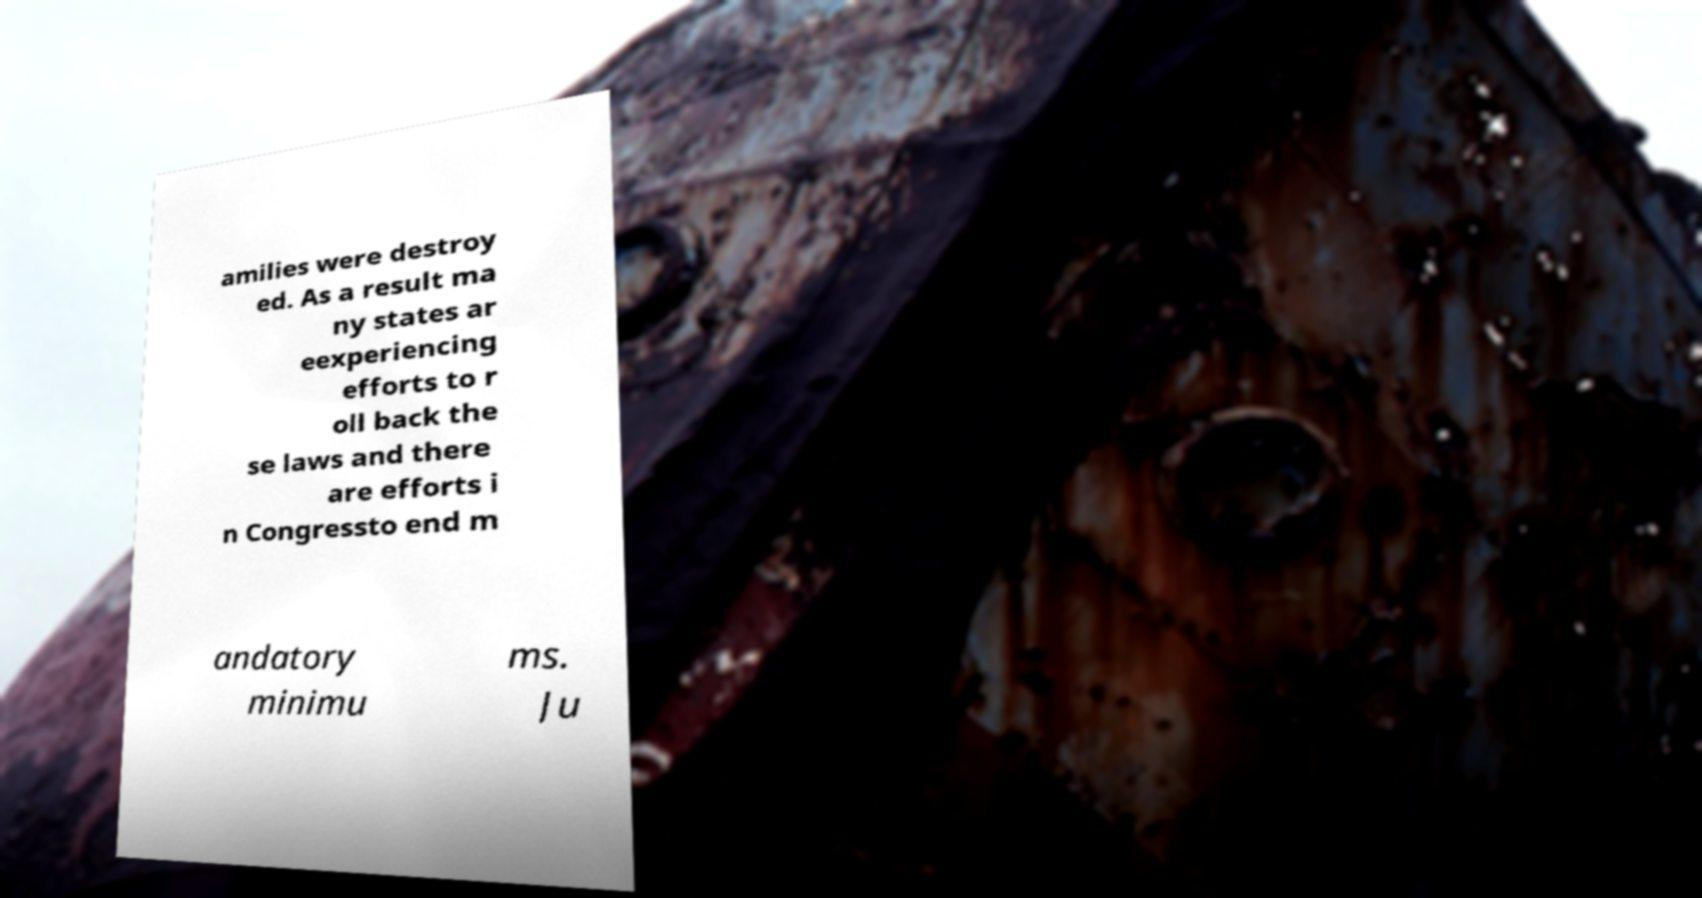Please identify and transcribe the text found in this image. amilies were destroy ed. As a result ma ny states ar eexperiencing efforts to r oll back the se laws and there are efforts i n Congressto end m andatory minimu ms. Ju 